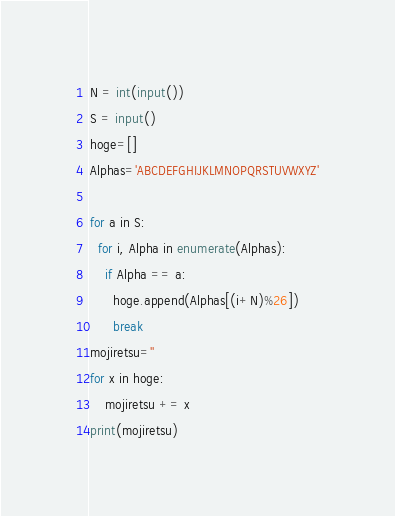Convert code to text. <code><loc_0><loc_0><loc_500><loc_500><_Python_>N = int(input())
S = input()
hoge=[]
Alphas='ABCDEFGHIJKLMNOPQRSTUVWXYZ'
 
for a in S:
  for i, Alpha in enumerate(Alphas):
    if Alpha == a:
      hoge.append(Alphas[(i+N)%26])
      break
mojiretsu=''
for x in hoge:
    mojiretsu += x
print(mojiretsu)</code> 